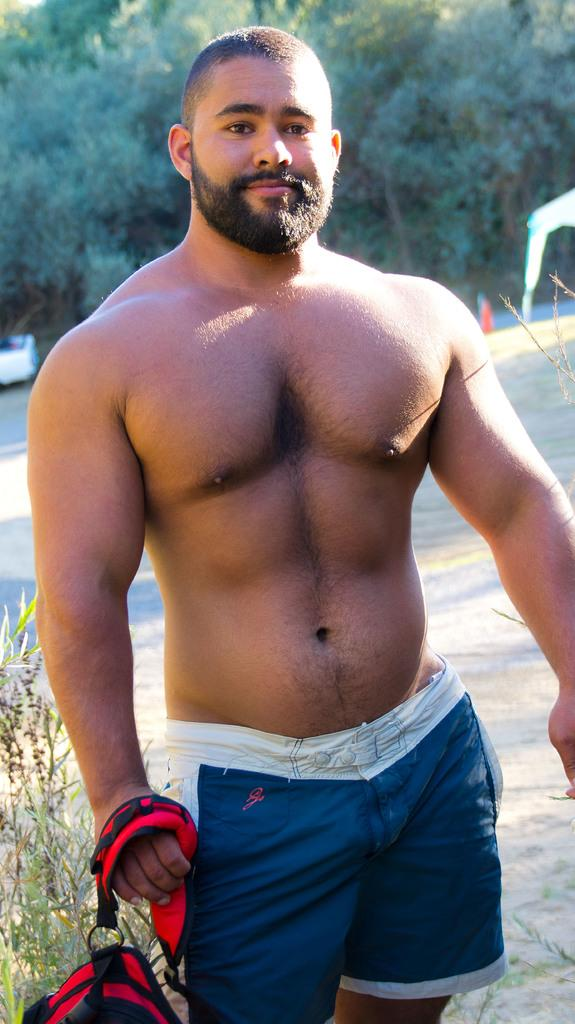What is the main subject of the image? There is a man in the image. What is the man's position in the image? The man is standing on the ground. What is the man wearing, or not wearing, in the image? The man is not wearing a shirt. What is the man holding in the image? The man is holding a bag. What can be seen in the background of the image? There are trees in the background of the image. What type of polish is the man applying to his nails in the image? There is no indication in the image that the man is applying polish to his nails, as he is not wearing any. 